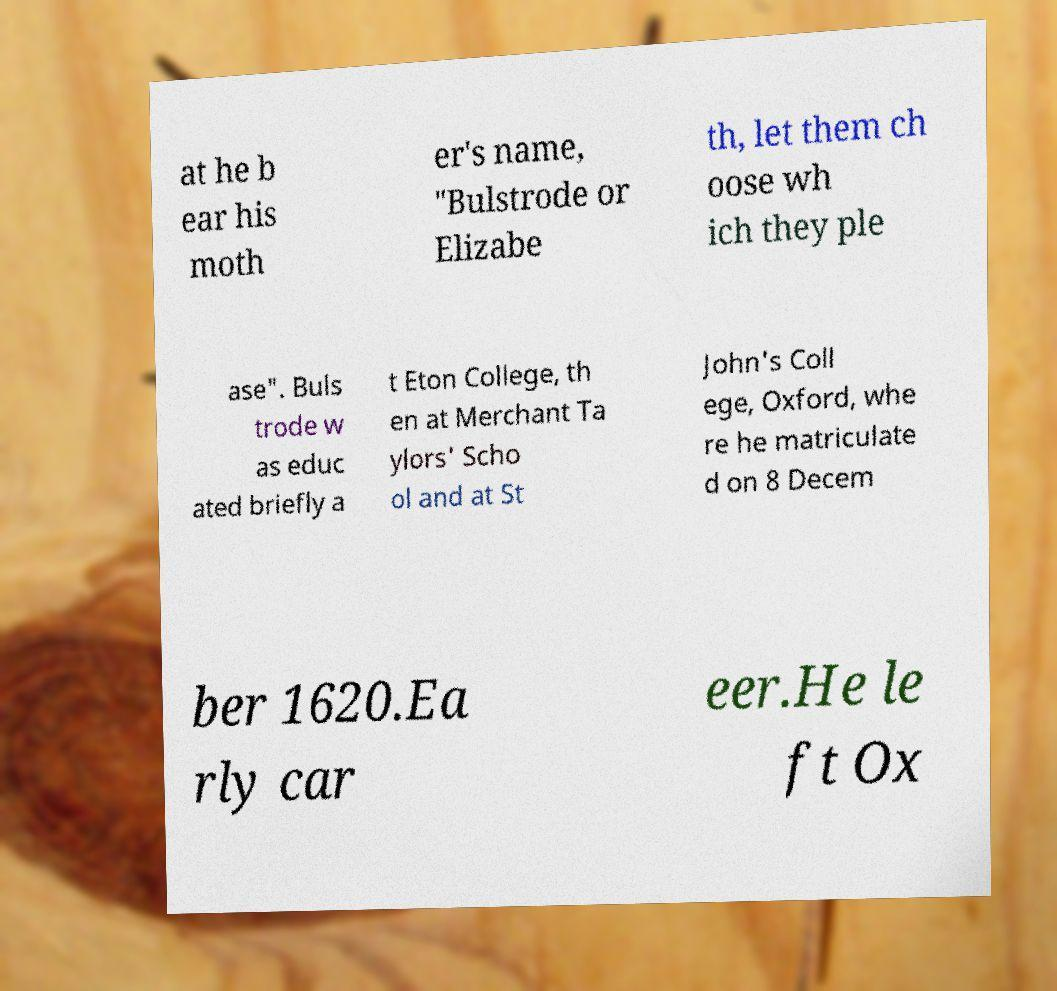Could you extract and type out the text from this image? at he b ear his moth er's name, "Bulstrode or Elizabe th, let them ch oose wh ich they ple ase". Buls trode w as educ ated briefly a t Eton College, th en at Merchant Ta ylors' Scho ol and at St John's Coll ege, Oxford, whe re he matriculate d on 8 Decem ber 1620.Ea rly car eer.He le ft Ox 